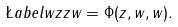Convert formula to latex. <formula><loc_0><loc_0><loc_500><loc_500>\L a b e l { w z z } w = \Phi ( z , w , w ) .</formula> 